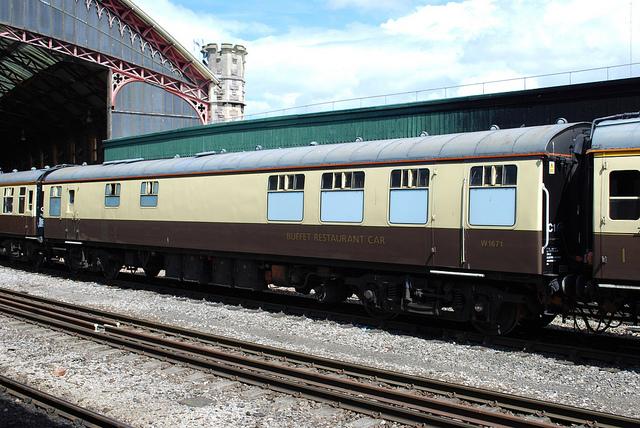Are there clouds visible?
Concise answer only. Yes. Is this a passenger or cargo train?
Keep it brief. Passenger. What car of the train is centered?
Be succinct. Buffet restaurant car. 